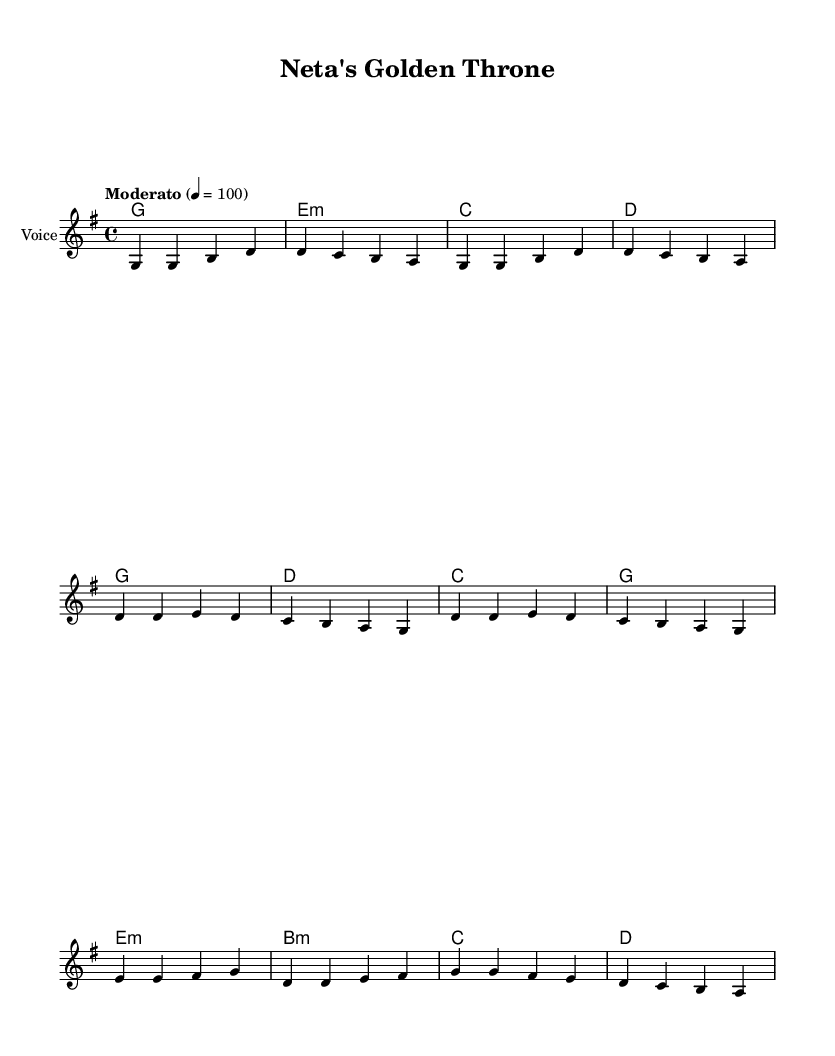What is the key signature of this music? The key signature is G major, which has one sharp (F#). This can be confirmed from the global section of the code where it states "\key g \major."
Answer: G major What is the time signature of this music? The time signature is 4/4, as indicated in the global section of the code with "\time 4/4." This means there are four beats per measure.
Answer: 4/4 What is the tempo marking for this piece? The tempo marking is 'Moderato', with a tempo of quarter note = 100. This is defined in the global section where it states "\tempo 'Moderato' 4 = 100."
Answer: Moderato How many verses are in this song? There are two verses in this song, each consisting of four lines of lyrics, retrieved from the verse_lyrics section of the code.
Answer: 2 What is the primary theme of this folk song? The primary theme of this folk song critiques corruption in regional governments, particularly highlighting the disparity between leaders and the common folk, as seen in the lyrics that discuss leaders on thrones and commoners' struggles.
Answer: Corruption How does the bridge contribute to the overall message of the song? The bridge emphasizes a call for change and unity among the people by stating that "the voice of change is growing strong," thus reinforcing the critical message against corruption and inspiring collective action among villagers.
Answer: Change and unity What style of lyrics characterizes this folk song? The lyrics are characterized by satirical elements that critique political leaders and their corruption, blending humor with serious themes typical of folk music. This can be inferred from the content of the verses and chorus which question political integrity.
Answer: Satirical 